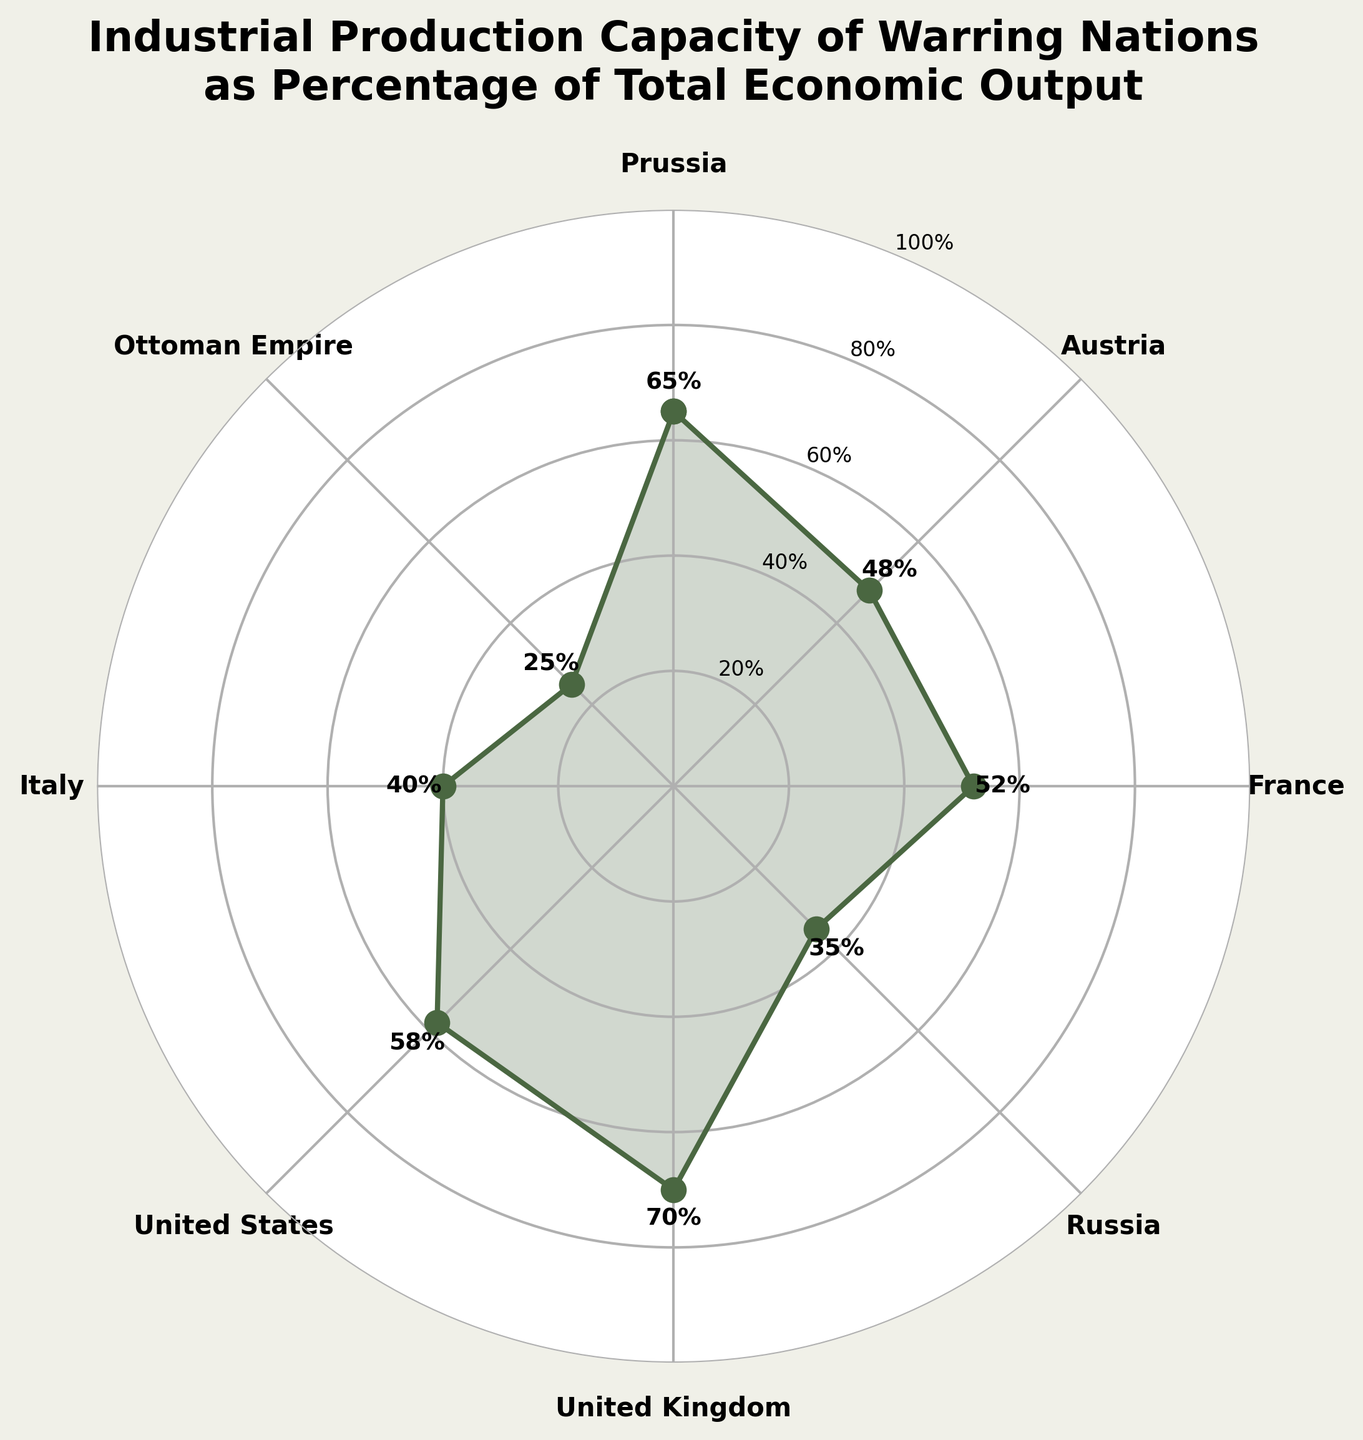What is the title of the figure? The title of the figure is displayed at the top center. It reads "Industrial Production Capacity of Warring Nations as Percentage of Total Economic Output".
Answer: "Industrial Production Capacity of Warring Nations as Percentage of Total Economic Output" Which country has the highest industrial production capacity? By looking at the values plotted on the figure, the United Kingdom has the highest percentage at 70%.
Answer: United Kingdom What's the difference in industrial production capacity between Prussia and Russia? Prussia has 65% and Russia has 35%. The difference is calculated by subtracting 35 from 65.
Answer: 30% Which countries have an industrial production capacity below 50%? By examining the plot, the countries below the 50% mark are Austria (48%), Russia (35%), Italy (40%), and the Ottoman Empire (25%).
Answer: Austria, Russia, Italy, Ottoman Empire Which country is closest to France in terms of industrial production capacity? France has 52%. The closest country to this percentage is Prussia with 65%.
Answer: Prussia Arrange the countries in descending order of their industrial production capacity. The percentages are: United Kingdom (70%), Prussia (65%), United States (58%), France (52%), Austria (48%), Italy (40%), Russia (35%), and Ottoman Empire (25%). Arranged in descending order: United Kingdom, Prussia, United States, France, Austria, Italy, Russia, Ottoman Empire.
Answer: United Kingdom, Prussia, United States, France, Austria, Italy, Russia, Ottoman Empire What is the combined industrial production capacity of the United Kingdom and the United States? United Kingdom has 70% and United States has 58%. Adding these together gives 70 + 58, which equals 128%.
Answer: 128% How many countries have an industrial production capacity over 50%? Countries over 50% are Prussia (65%), France (52%), United Kingdom (70%), and United States (58%). So, there are 4 countries in total.
Answer: 4 Which country has the lowest industrial production capacity? The figure shows that the Ottoman Empire has the lowest industrial production capacity at 25%.
Answer: Ottoman Empire Compare the industrial production capacities of Italy and Austria. Which country has a higher value and by how much? Italy has 40% and Austria has 48%. Austria's capacity is higher. The difference is 48 - 40 = 8%.
Answer: Austria by 8% 